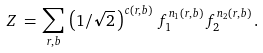Convert formula to latex. <formula><loc_0><loc_0><loc_500><loc_500>Z \, = \, \sum _ { r , b } \, \left ( 1 / \sqrt { 2 } \, \right ) ^ { c ( r , b ) } \, f _ { 1 } ^ { n _ { 1 } ( r , b ) } \, f _ { 2 } ^ { n _ { 2 } ( r , b ) } \, .</formula> 